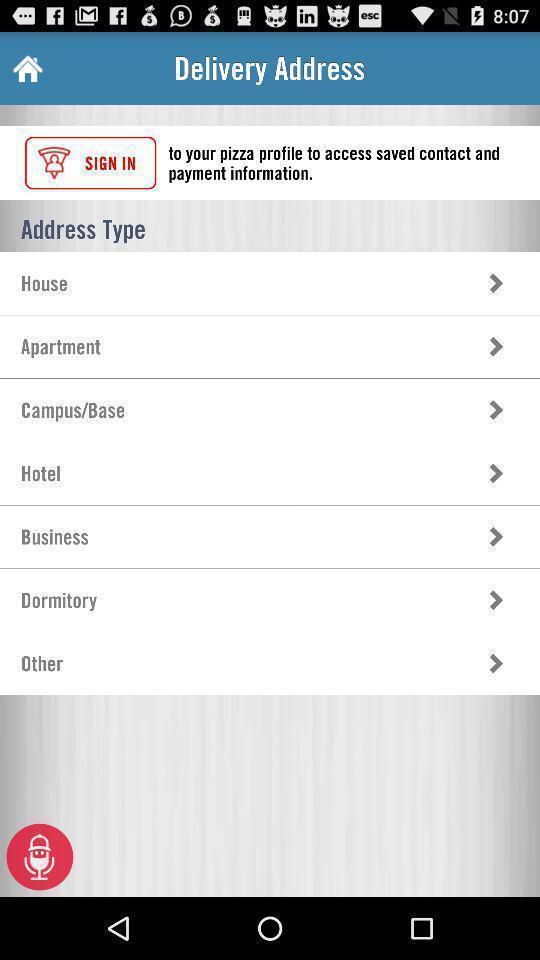Describe the visual elements of this screenshot. Screen shows an address type for setup. 